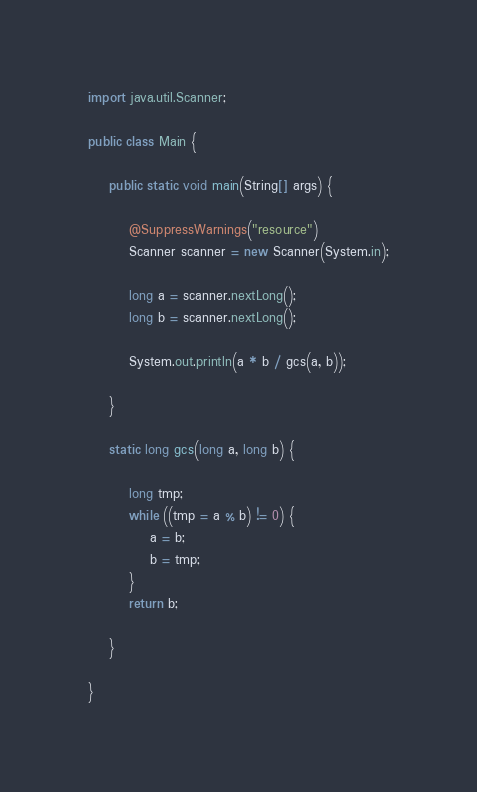<code> <loc_0><loc_0><loc_500><loc_500><_Java_>import java.util.Scanner;

public class Main {

	public static void main(String[] args) {

		@SuppressWarnings("resource")
		Scanner scanner = new Scanner(System.in);

		long a = scanner.nextLong();
		long b = scanner.nextLong();

		System.out.println(a * b / gcs(a, b));

	}

	static long gcs(long a, long b) {

		long tmp;
		while ((tmp = a % b) != 0) {
			a = b;
			b = tmp;
		}
		return b;

	}

}</code> 